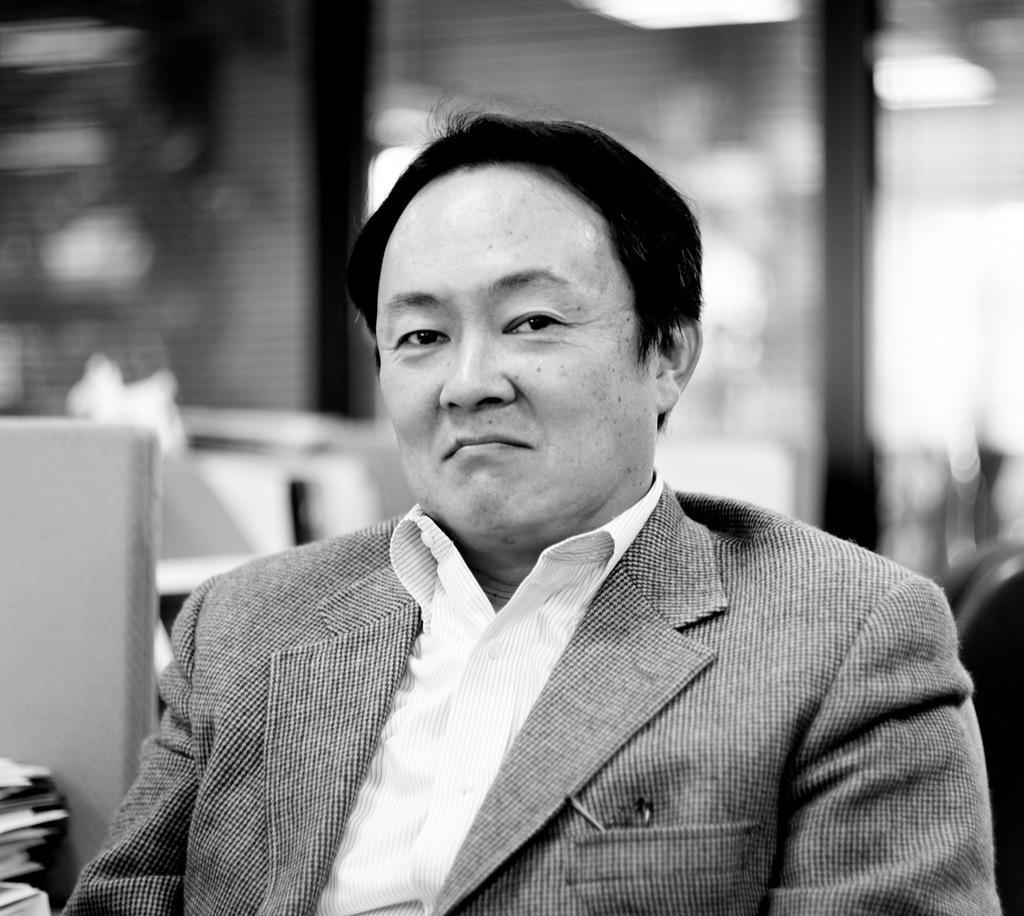What is the main subject of the image? There is a person in the image. What type of clothing is the person wearing? The person is wearing a blazer and a shirt. What can be seen to the left of the person? There are objects to the left of the person. How would you describe the background of the image? The background of the image is blurred. What is the color scheme of the image? The image is black and white. How many cakes are on the person's tail in the image? There is no tail present on the person in the image, and therefore no cakes can be found there. What type of riddle is the person solving in the image? There is no riddle present in the image, and the person's activity cannot be determined from the provided facts. 